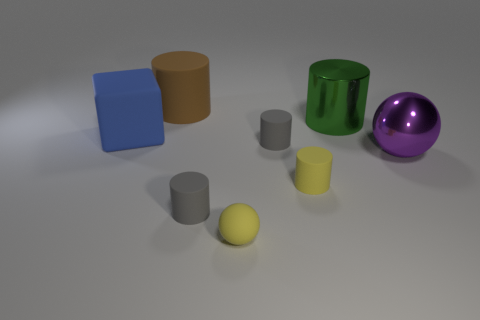Can you tell me the colors of the cylindrical objects from left to right? From left to right, the cylindrical objects are brown, green, and yellow, respectively, each with their own distinctive hue. 